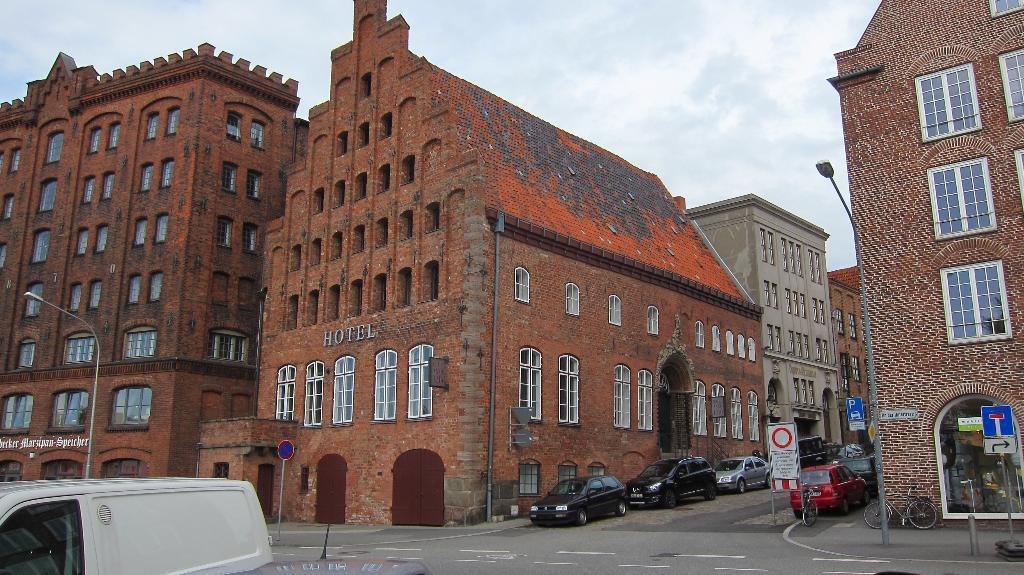How would you summarize this image in a sentence or two? In this image there are some buildings, in the center there are some vehicles on the road. And also we could see some poles, lights and some boards. On the right side there are two cycles, at the bottom there is a road. On the road there is one truck, on the top of the image there is sky. 